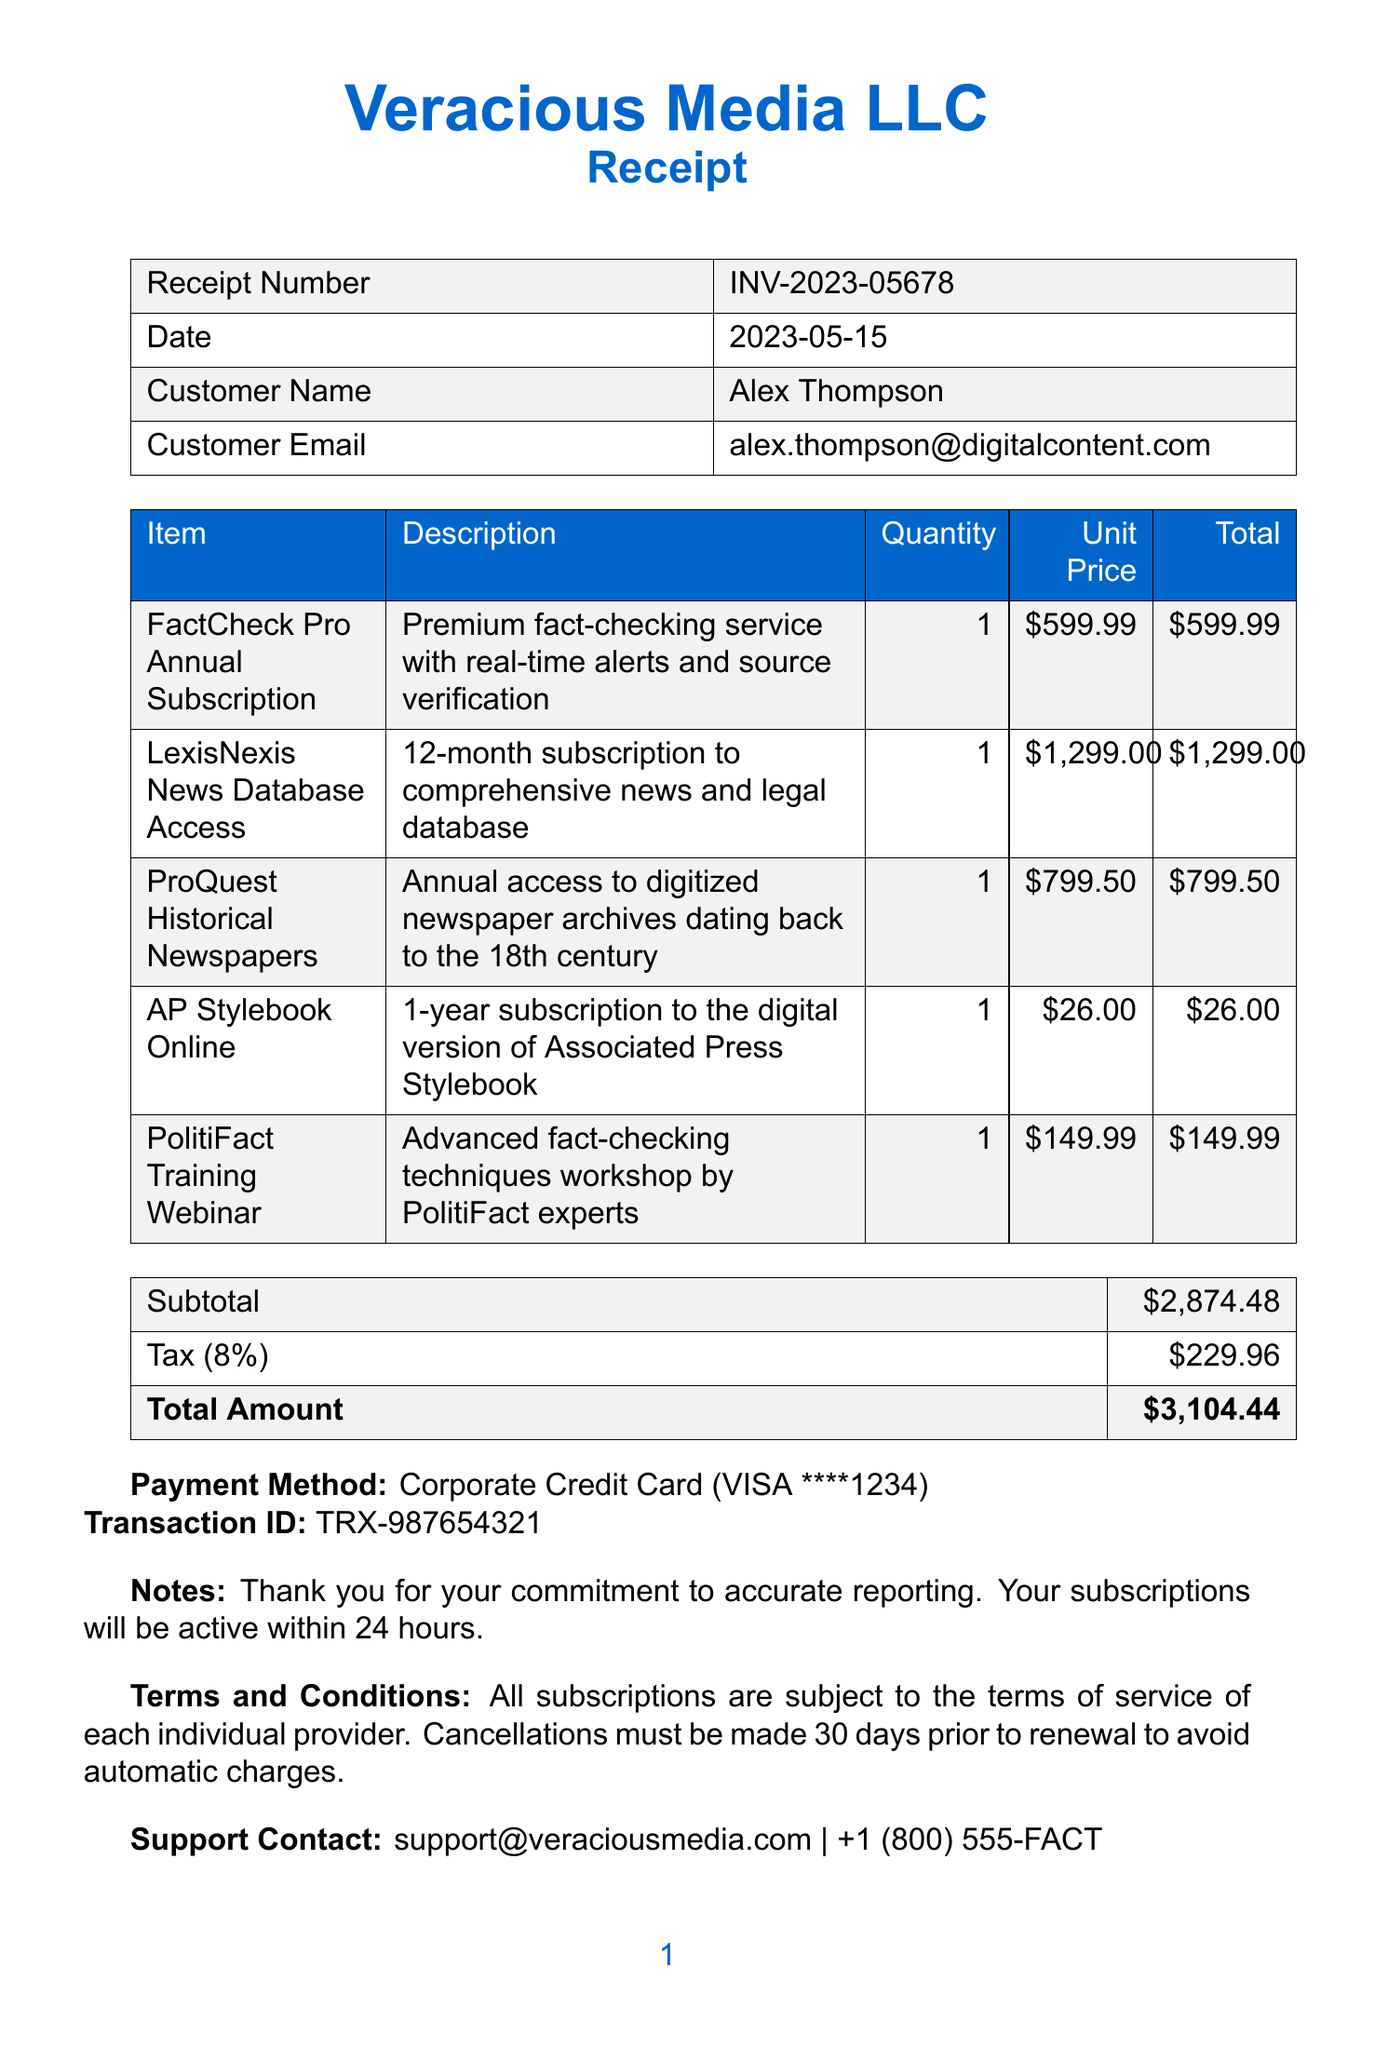what is the receipt number? The receipt number is stated at the top of the document, which identifies this particular transaction.
Answer: INV-2023-05678 who is the customer? The document lists the customer name along with their email address for contact purposes.
Answer: Alex Thompson what is the total amount charged? The total amount is provided at the bottom of the receipt summarizing the costs of services and taxes involved.
Answer: $3104.44 how many items are listed in the receipt? The number of items is counted from the itemized list provided in the receipt.
Answer: 5 what type of payment method was used? The payment method details are specified under the payment section of the receipt.
Answer: Corporate Credit Card (VISA ****1234) which item has the highest cost? The item prices are compared to determine which one is the most expensive as listed in the document.
Answer: LexisNexis News Database Access what is the tax rate applied? The tax rate is indicated in the receipt alongside the tax amount, showing the calculation basis for taxes.
Answer: 8% what is the description of the AP Stylebook Online? The description provides insight into what is included with the subscription listed in the receipt.
Answer: 1-year subscription to the digital version of Associated Press Stylebook 